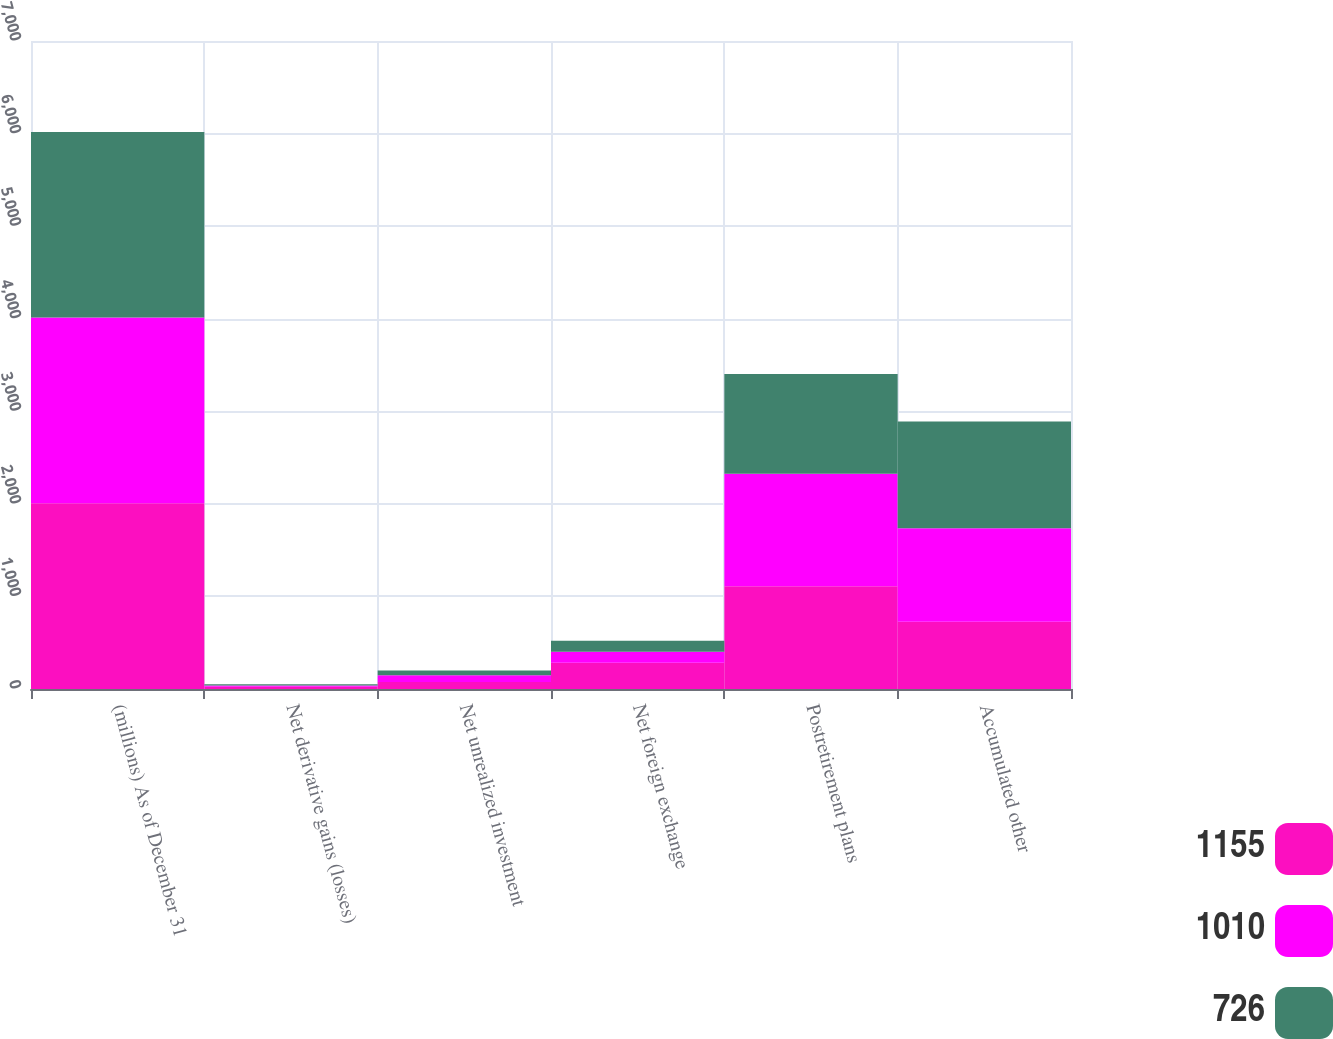<chart> <loc_0><loc_0><loc_500><loc_500><stacked_bar_chart><ecel><fcel>(millions) As of December 31<fcel>Net derivative gains (losses)<fcel>Net unrealized investment<fcel>Net foreign exchange<fcel>Postretirement plans<fcel>Accumulated other<nl><fcel>1155<fcel>2007<fcel>24<fcel>76<fcel>284<fcel>1110<fcel>726<nl><fcel>1010<fcel>2006<fcel>15<fcel>73<fcel>118<fcel>1216<fcel>1010<nl><fcel>726<fcel>2005<fcel>11<fcel>52<fcel>119<fcel>1077<fcel>1155<nl></chart> 